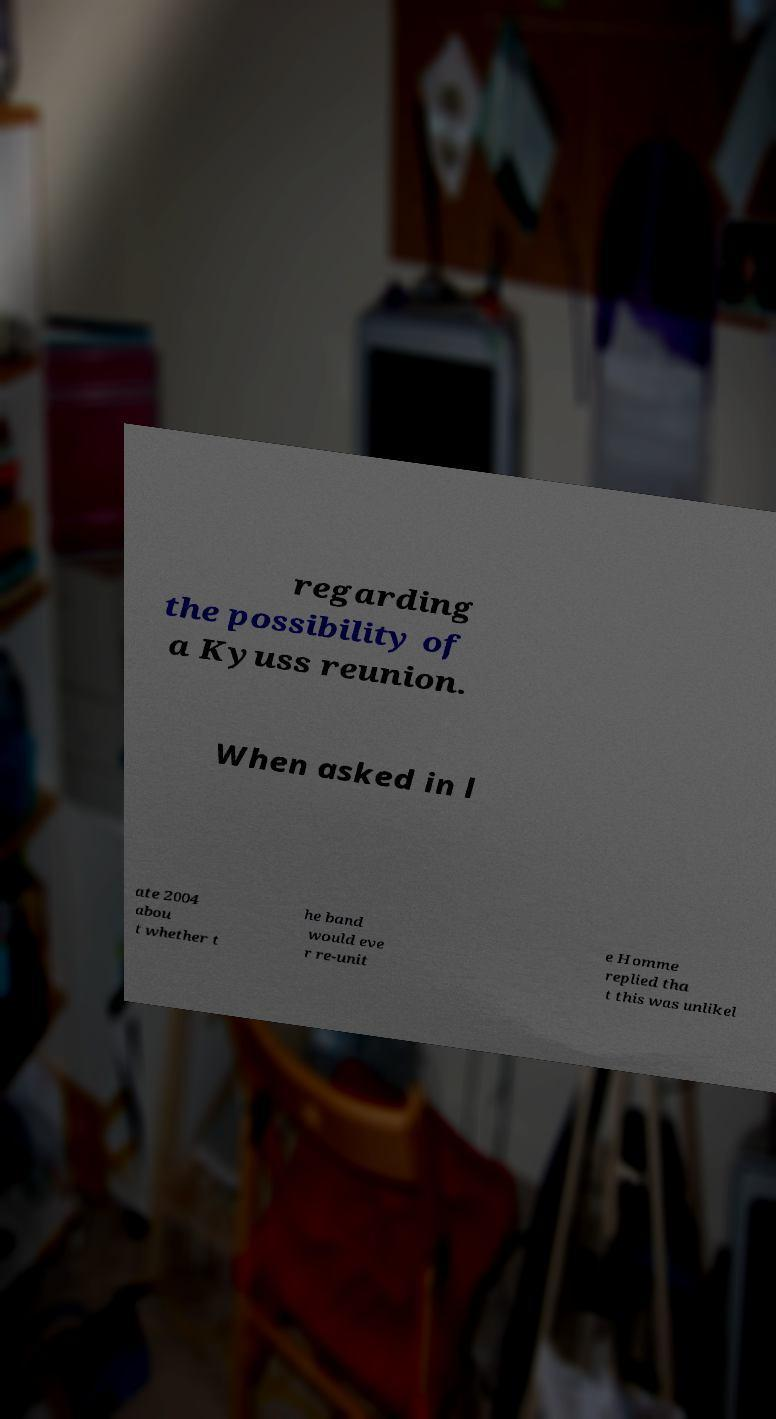What messages or text are displayed in this image? I need them in a readable, typed format. regarding the possibility of a Kyuss reunion. When asked in l ate 2004 abou t whether t he band would eve r re-unit e Homme replied tha t this was unlikel 